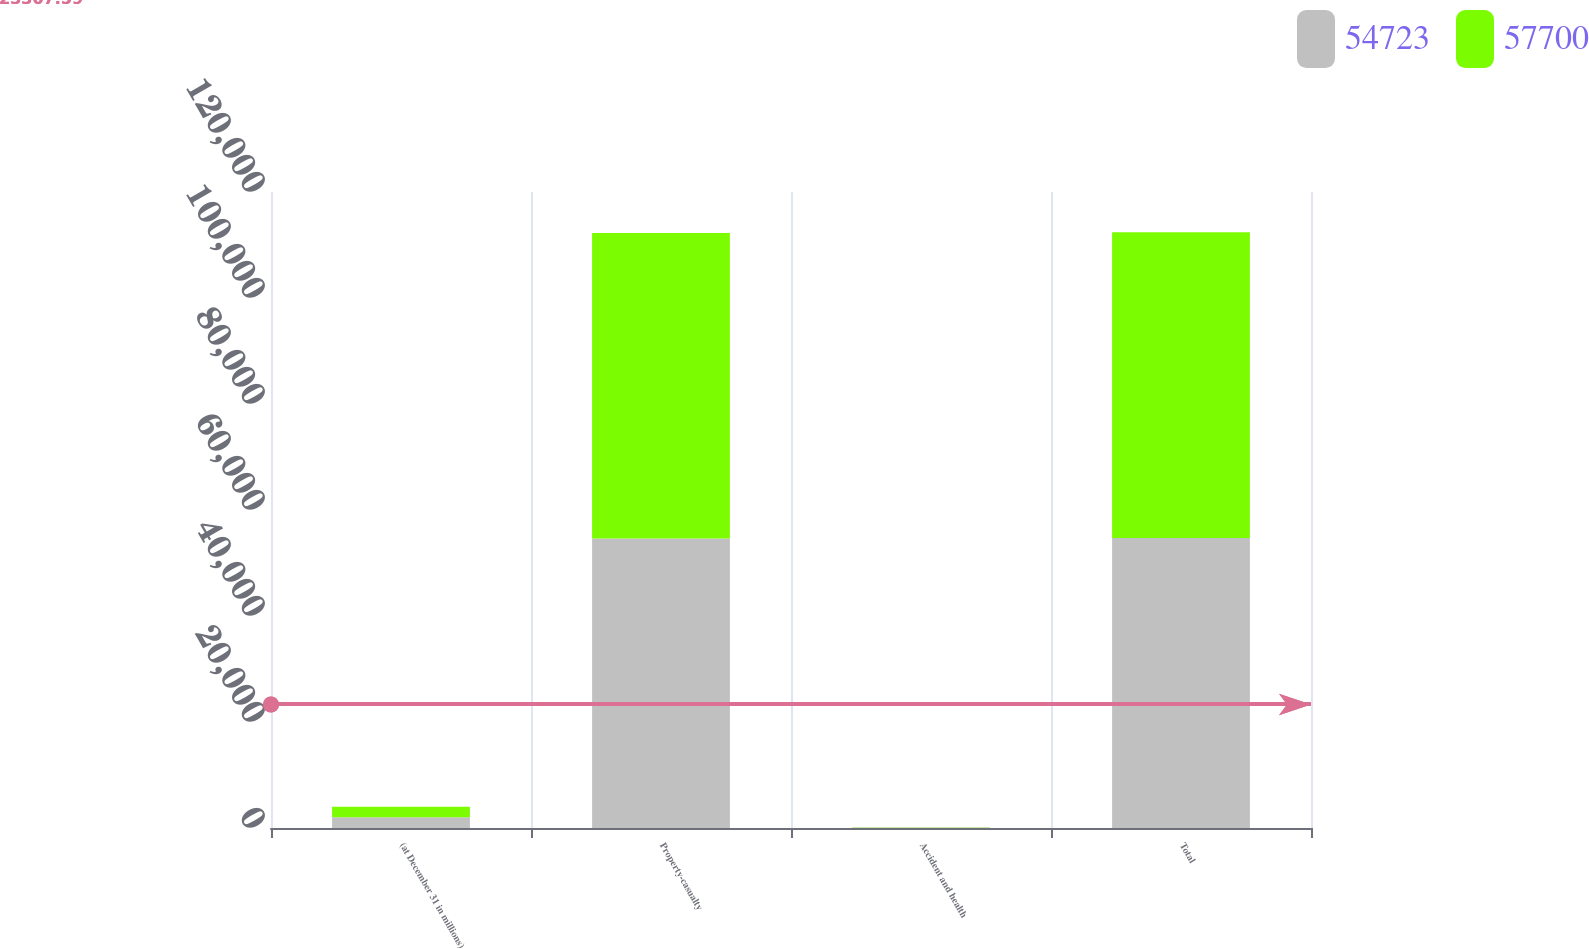Convert chart. <chart><loc_0><loc_0><loc_500><loc_500><stacked_bar_chart><ecel><fcel>(at December 31 in millions)<fcel>Property-casualty<fcel>Accident and health<fcel>Total<nl><fcel>54723<fcel>2008<fcel>54646<fcel>77<fcel>54723<nl><fcel>57700<fcel>2007<fcel>57619<fcel>81<fcel>57700<nl></chart> 